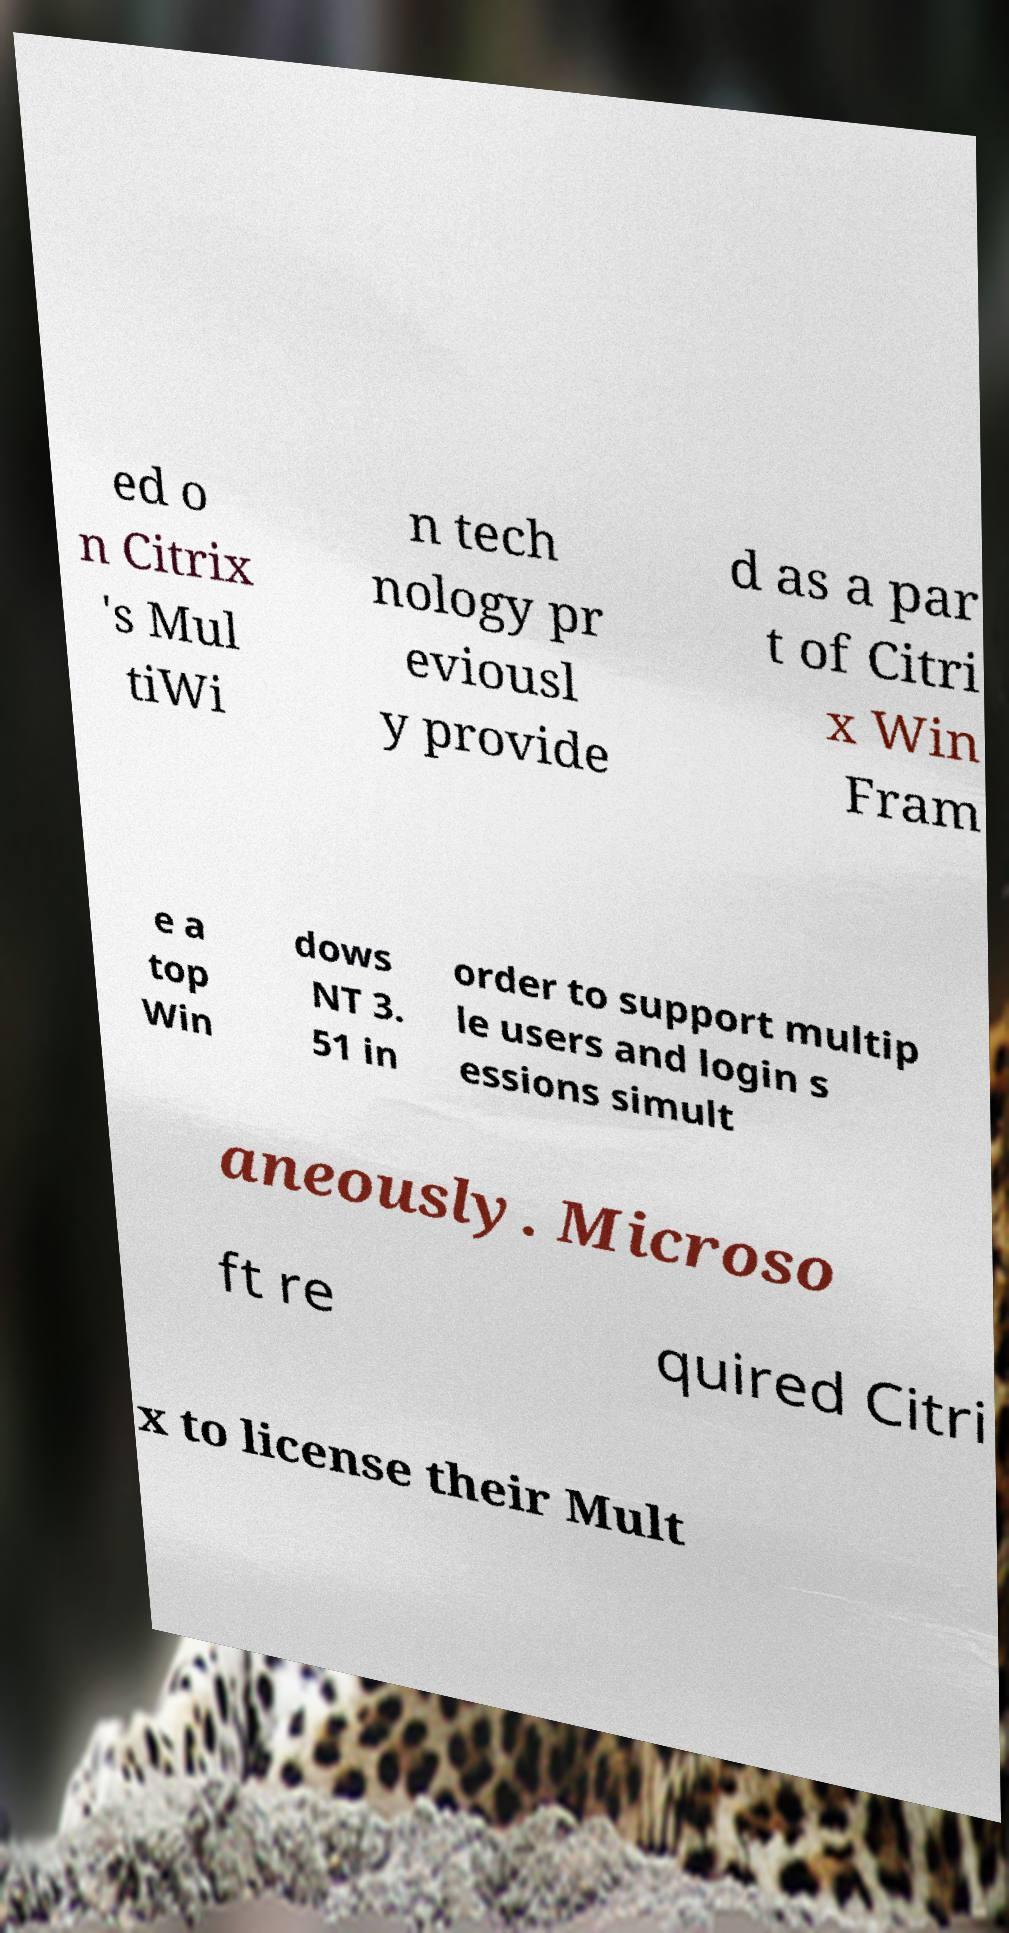Can you read and provide the text displayed in the image?This photo seems to have some interesting text. Can you extract and type it out for me? ed o n Citrix 's Mul tiWi n tech nology pr eviousl y provide d as a par t of Citri x Win Fram e a top Win dows NT 3. 51 in order to support multip le users and login s essions simult aneously. Microso ft re quired Citri x to license their Mult 